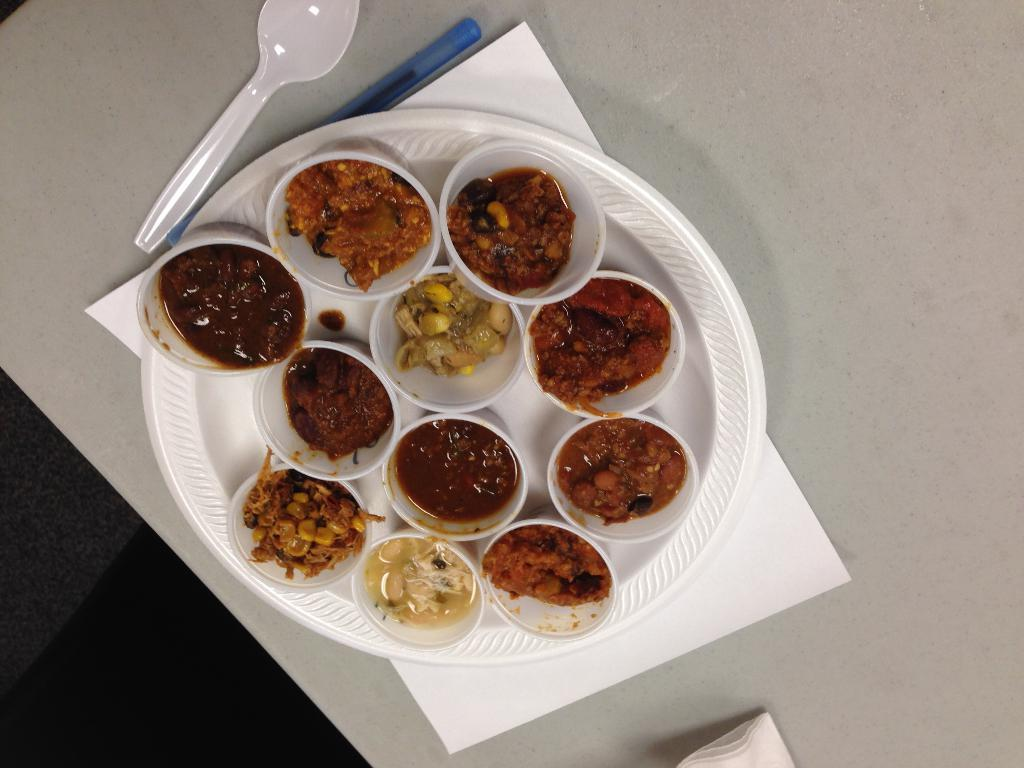What type of objects can be seen in the image? There are food items in the image. How are the food items arranged or presented? The food items are in a plate. What utensil is present in the image? There is a spoon in the image. Is there any writing instrument visible in the image? Yes, there is a pen in the image. How many sisters are present in the image? There are no sisters mentioned or depicted in the image. 